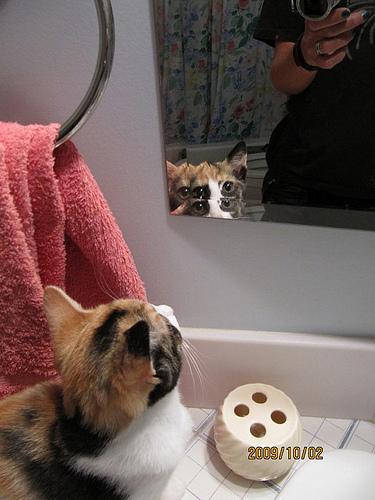How old is this picture?
Answer briefly. 2009. Is the cat looking in the mirror?
Answer briefly. Yes. What kind of mirror is this?
Be succinct. Bathroom. 